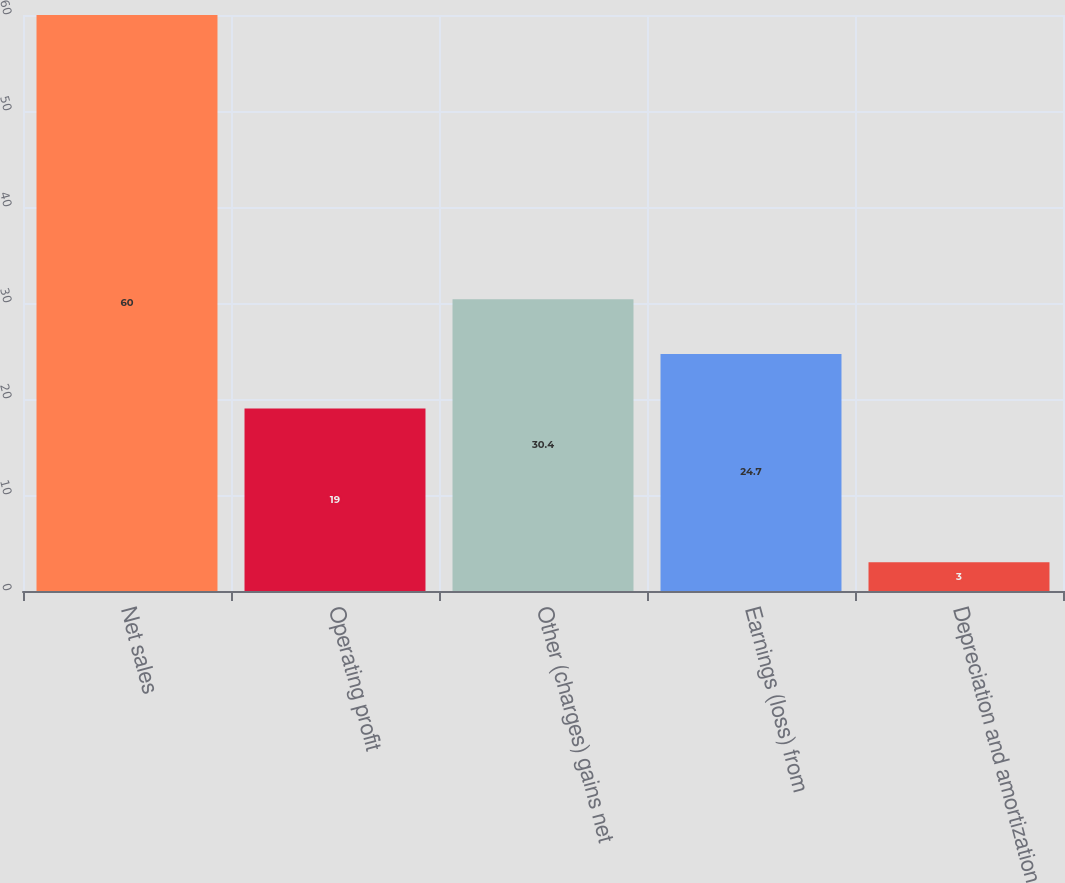Convert chart to OTSL. <chart><loc_0><loc_0><loc_500><loc_500><bar_chart><fcel>Net sales<fcel>Operating profit<fcel>Other (charges) gains net<fcel>Earnings (loss) from<fcel>Depreciation and amortization<nl><fcel>60<fcel>19<fcel>30.4<fcel>24.7<fcel>3<nl></chart> 